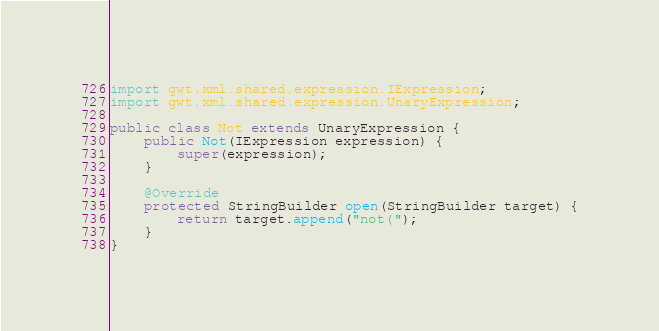<code> <loc_0><loc_0><loc_500><loc_500><_Java_>
import gwt.xml.shared.expression.IExpression;
import gwt.xml.shared.expression.UnaryExpression;

public class Not extends UnaryExpression {
	public Not(IExpression expression) {
		super(expression);
	}

	@Override
	protected StringBuilder open(StringBuilder target) {
		return target.append("not(");
	}
}
</code> 